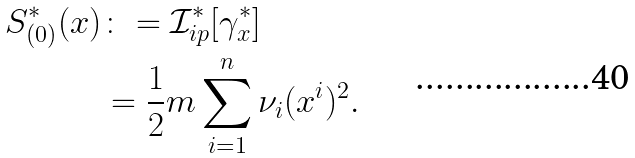Convert formula to latex. <formula><loc_0><loc_0><loc_500><loc_500>S _ { ( 0 ) } ^ { \ast } ( x ) & \colon = \mathcal { I } _ { i p } ^ { \ast } [ \gamma _ { x } ^ { \ast } ] \\ & = \frac { 1 } { 2 } m \sum _ { i = 1 } ^ { n } \nu _ { i } ( x ^ { i } ) ^ { 2 } .</formula> 